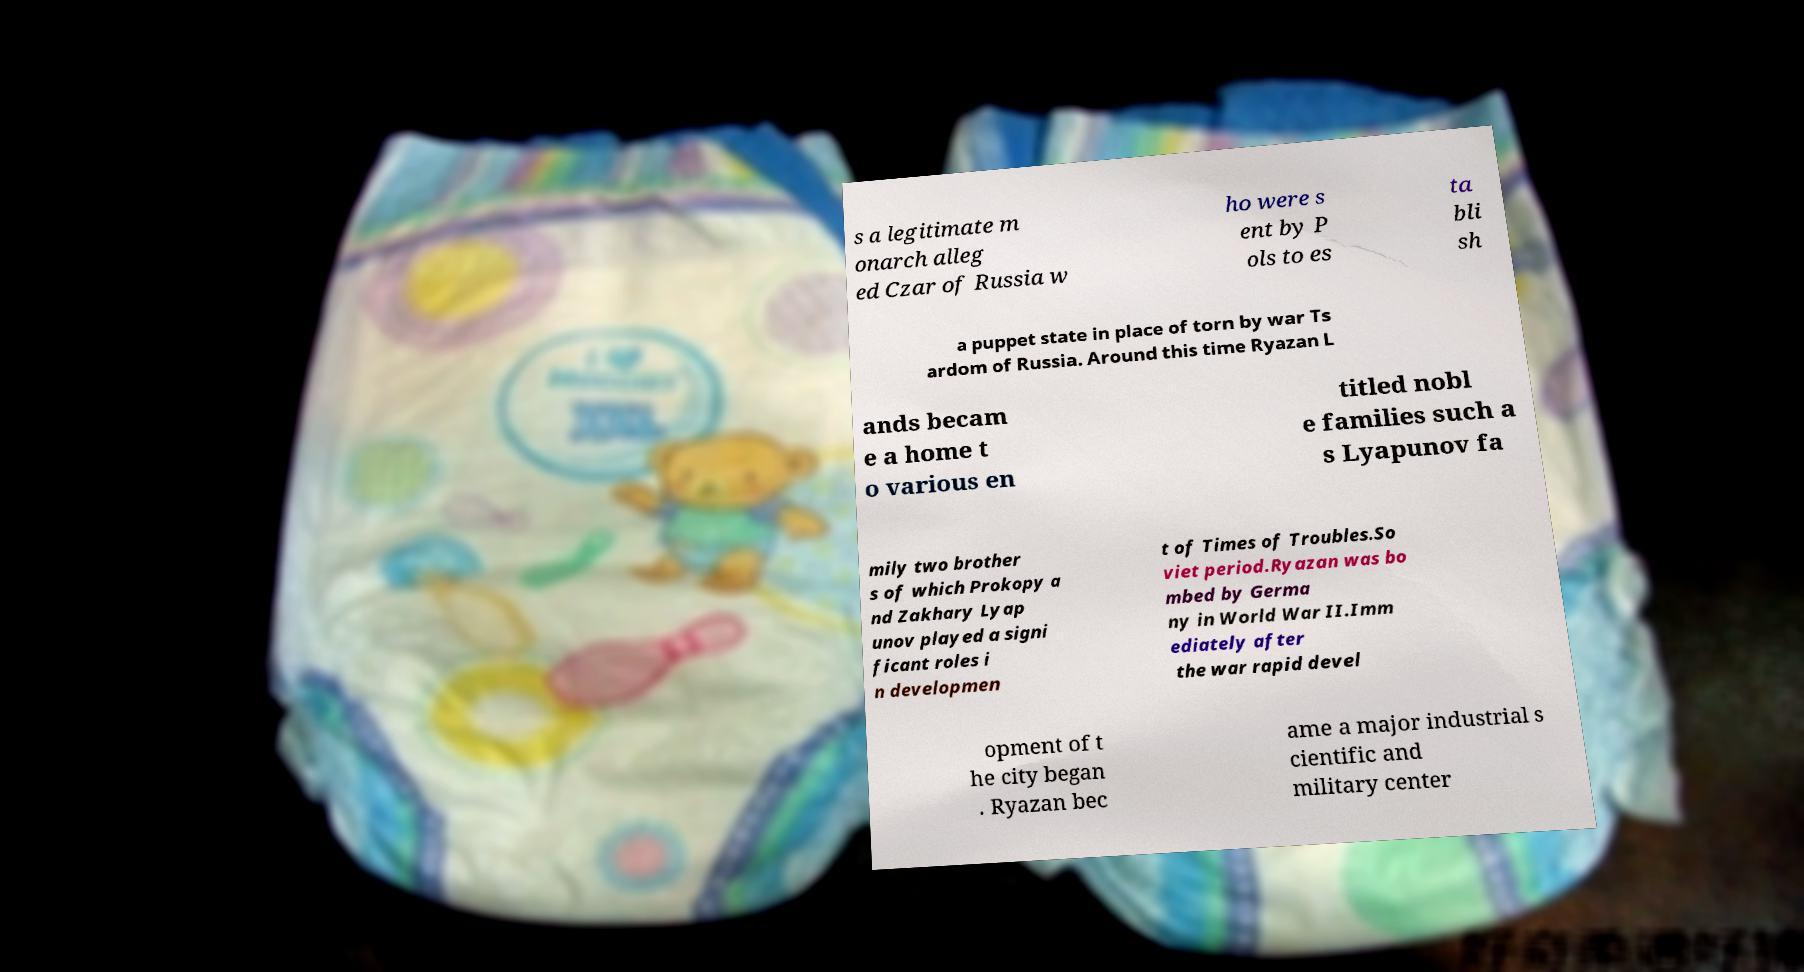There's text embedded in this image that I need extracted. Can you transcribe it verbatim? s a legitimate m onarch alleg ed Czar of Russia w ho were s ent by P ols to es ta bli sh a puppet state in place of torn by war Ts ardom of Russia. Around this time Ryazan L ands becam e a home t o various en titled nobl e families such a s Lyapunov fa mily two brother s of which Prokopy a nd Zakhary Lyap unov played a signi ficant roles i n developmen t of Times of Troubles.So viet period.Ryazan was bo mbed by Germa ny in World War II.Imm ediately after the war rapid devel opment of t he city began . Ryazan bec ame a major industrial s cientific and military center 